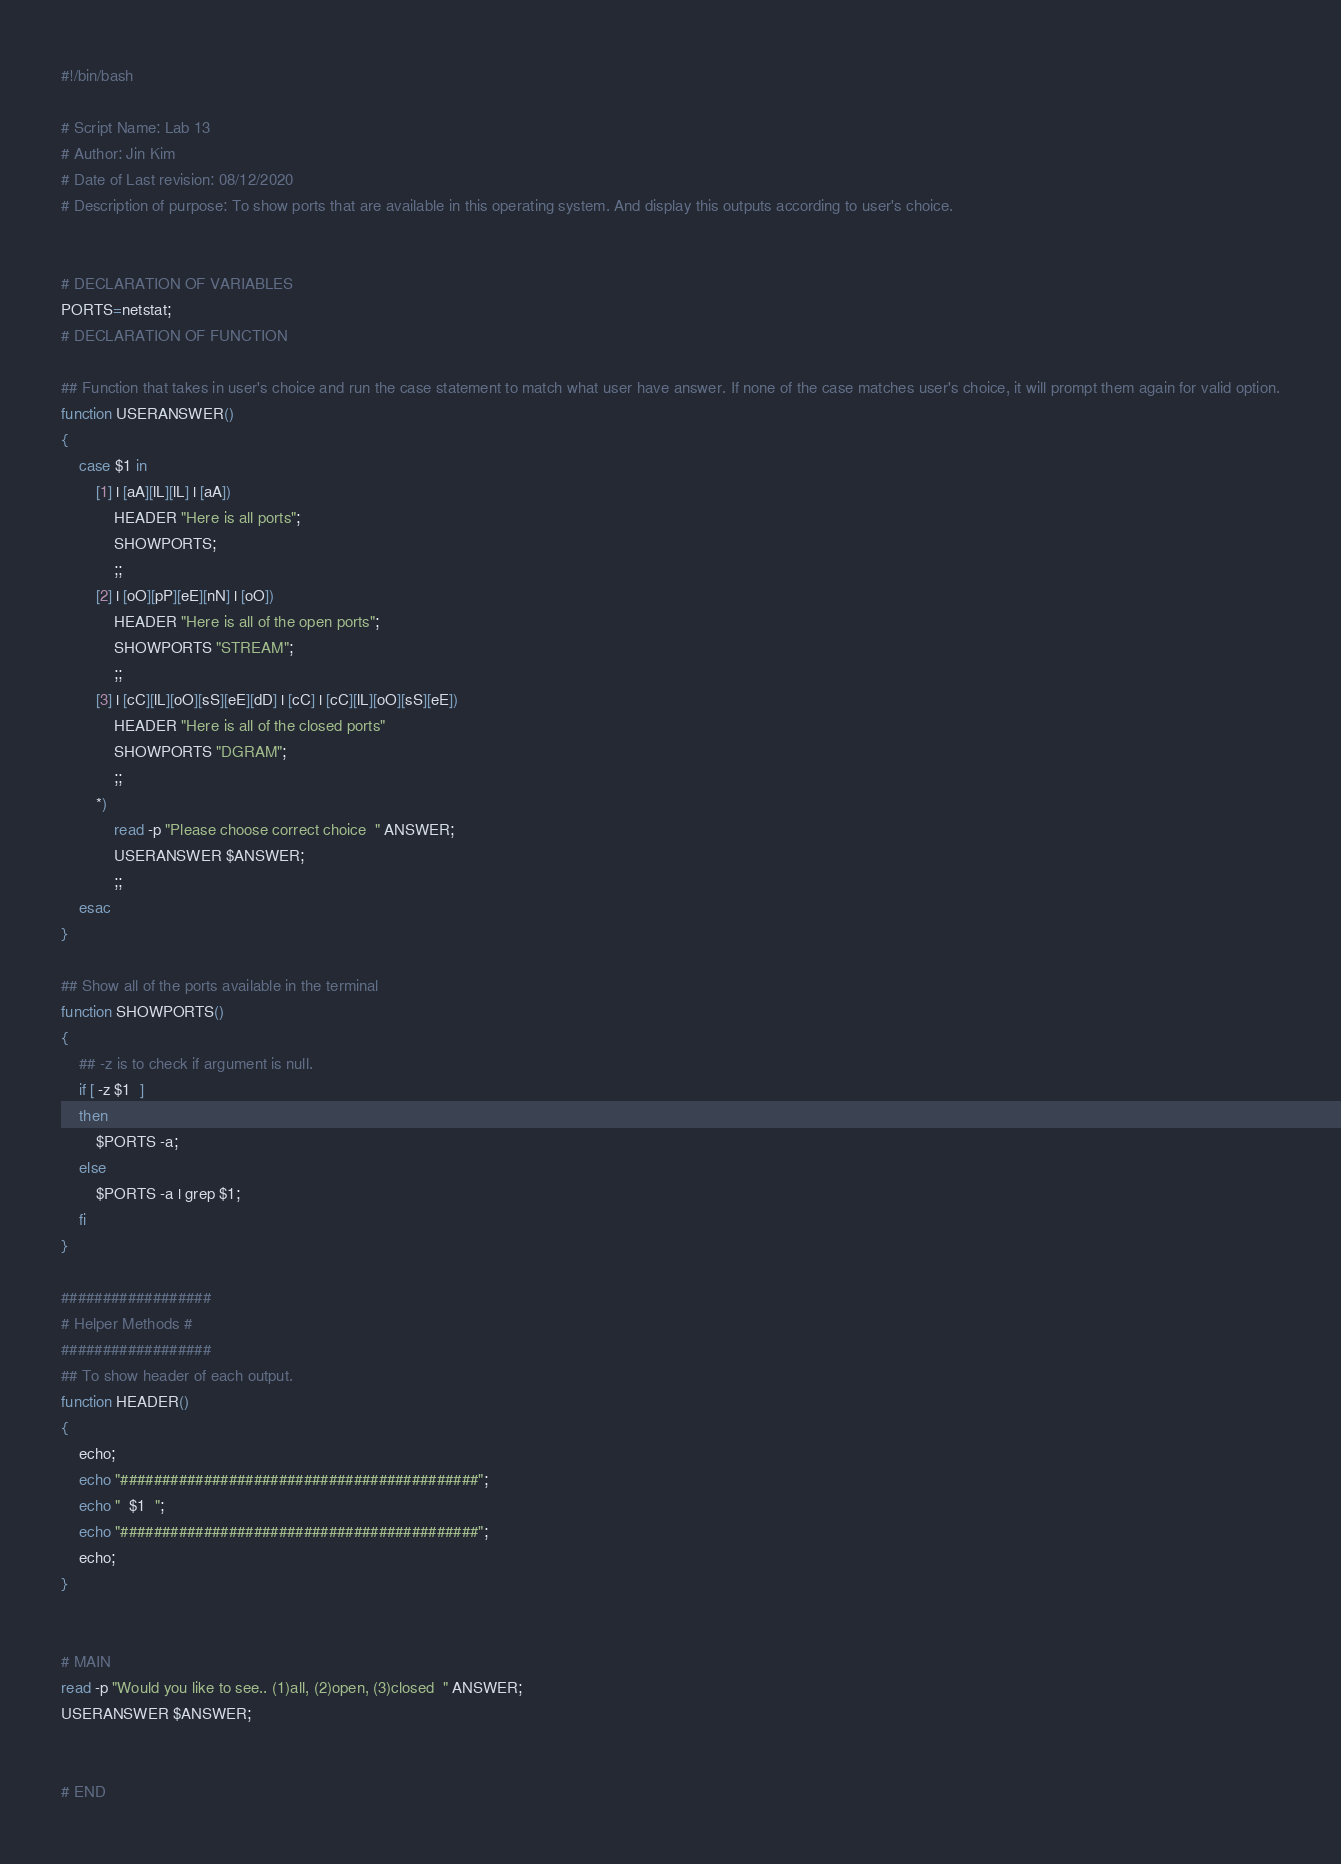<code> <loc_0><loc_0><loc_500><loc_500><_Bash_>#!/bin/bash

# Script Name: Lab 13
# Author: Jin Kim
# Date of Last revision: 08/12/2020
# Description of purpose: To show ports that are available in this operating system. And display this outputs according to user's choice.


# DECLARATION OF VARIABLES
PORTS=netstat;
# DECLARATION OF FUNCTION

## Function that takes in user's choice and run the case statement to match what user have answer. If none of the case matches user's choice, it will prompt them again for valid option.
function USERANSWER()
{
    case $1 in
        [1] | [aA][lL][lL] | [aA])
            HEADER "Here is all ports";
            SHOWPORTS;
            ;;
        [2] | [oO][pP][eE][nN] | [oO])
            HEADER "Here is all of the open ports";
            SHOWPORTS "STREAM";
            ;;
        [3] | [cC][lL][oO][sS][eE][dD] | [cC] | [cC][lL][oO][sS][eE])
            HEADER "Here is all of the closed ports"
            SHOWPORTS "DGRAM";
            ;;
        *)
            read -p "Please choose correct choice  " ANSWER;
            USERANSWER $ANSWER;
            ;;
    esac
}

## Show all of the ports available in the terminal
function SHOWPORTS()
{
    ## -z is to check if argument is null.
    if [ -z $1  ]
    then
        $PORTS -a;
    else
        $PORTS -a | grep $1;
    fi
}

##################
# Helper Methods #
##################
## To show header of each output.
function HEADER()
{
    echo;
    echo "###########################################";
    echo "  $1  ";
    echo "###########################################";
    echo;
}


# MAIN
read -p "Would you like to see.. (1)all, (2)open, (3)closed  " ANSWER; 
USERANSWER $ANSWER;


# END

</code> 